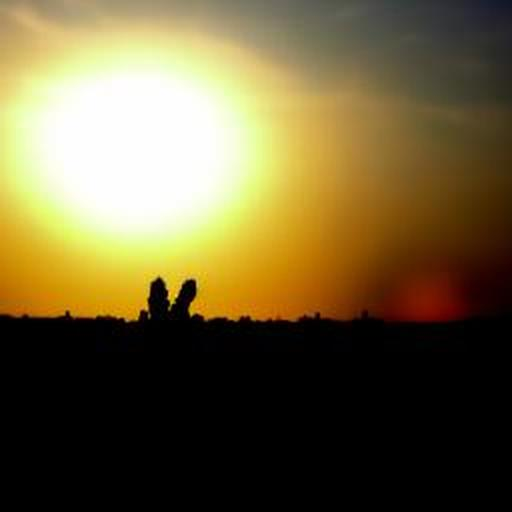What emotions might this image evoke? This image could evoke feelings of tranquility and reflection due to the serene sunset and the solitary figures. It might also inspire a sense of connection or contemplation on the passage of time. 